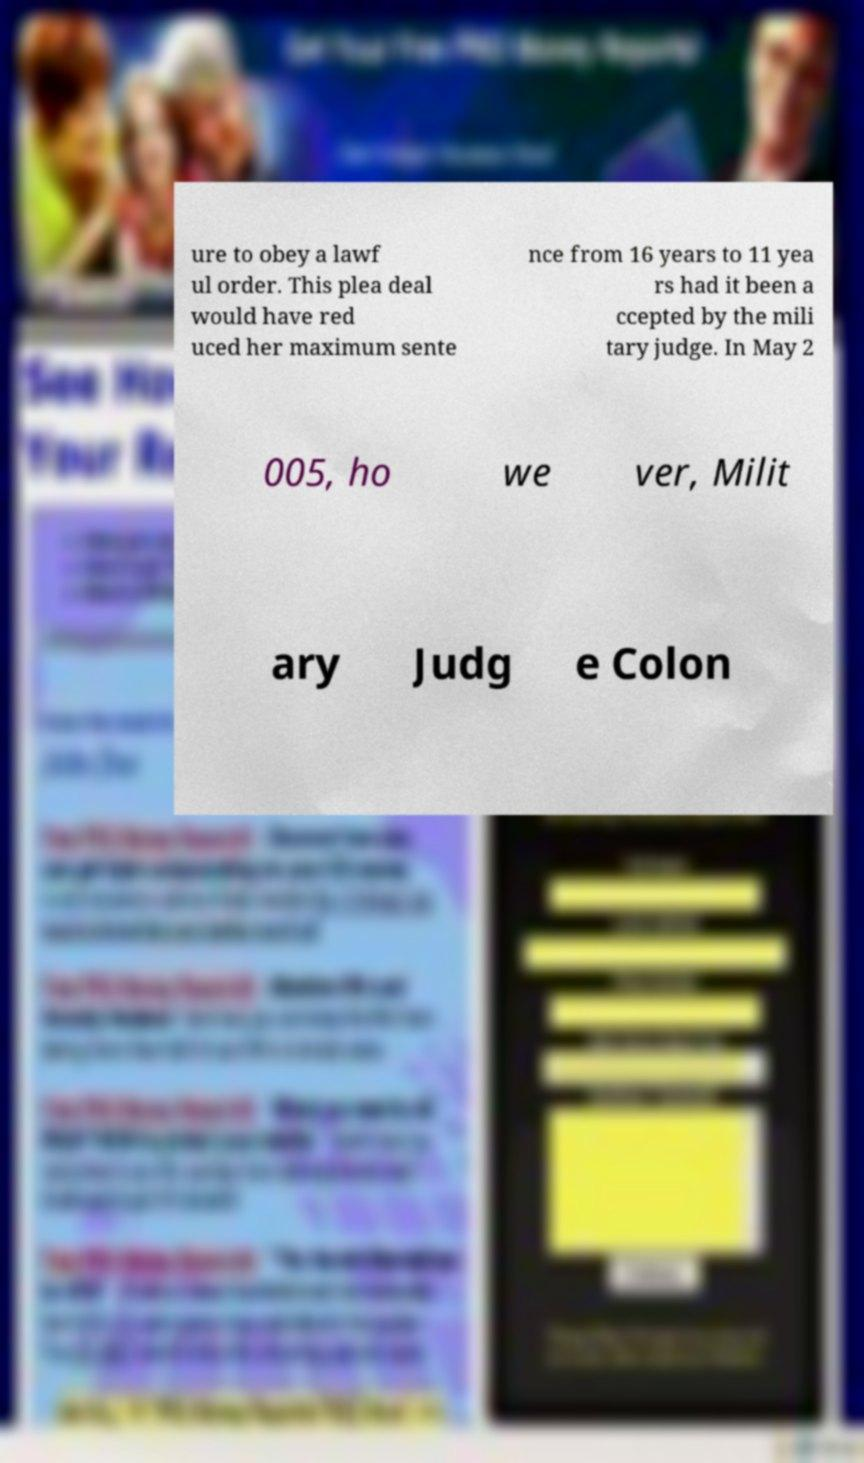Please identify and transcribe the text found in this image. ure to obey a lawf ul order. This plea deal would have red uced her maximum sente nce from 16 years to 11 yea rs had it been a ccepted by the mili tary judge. In May 2 005, ho we ver, Milit ary Judg e Colon 